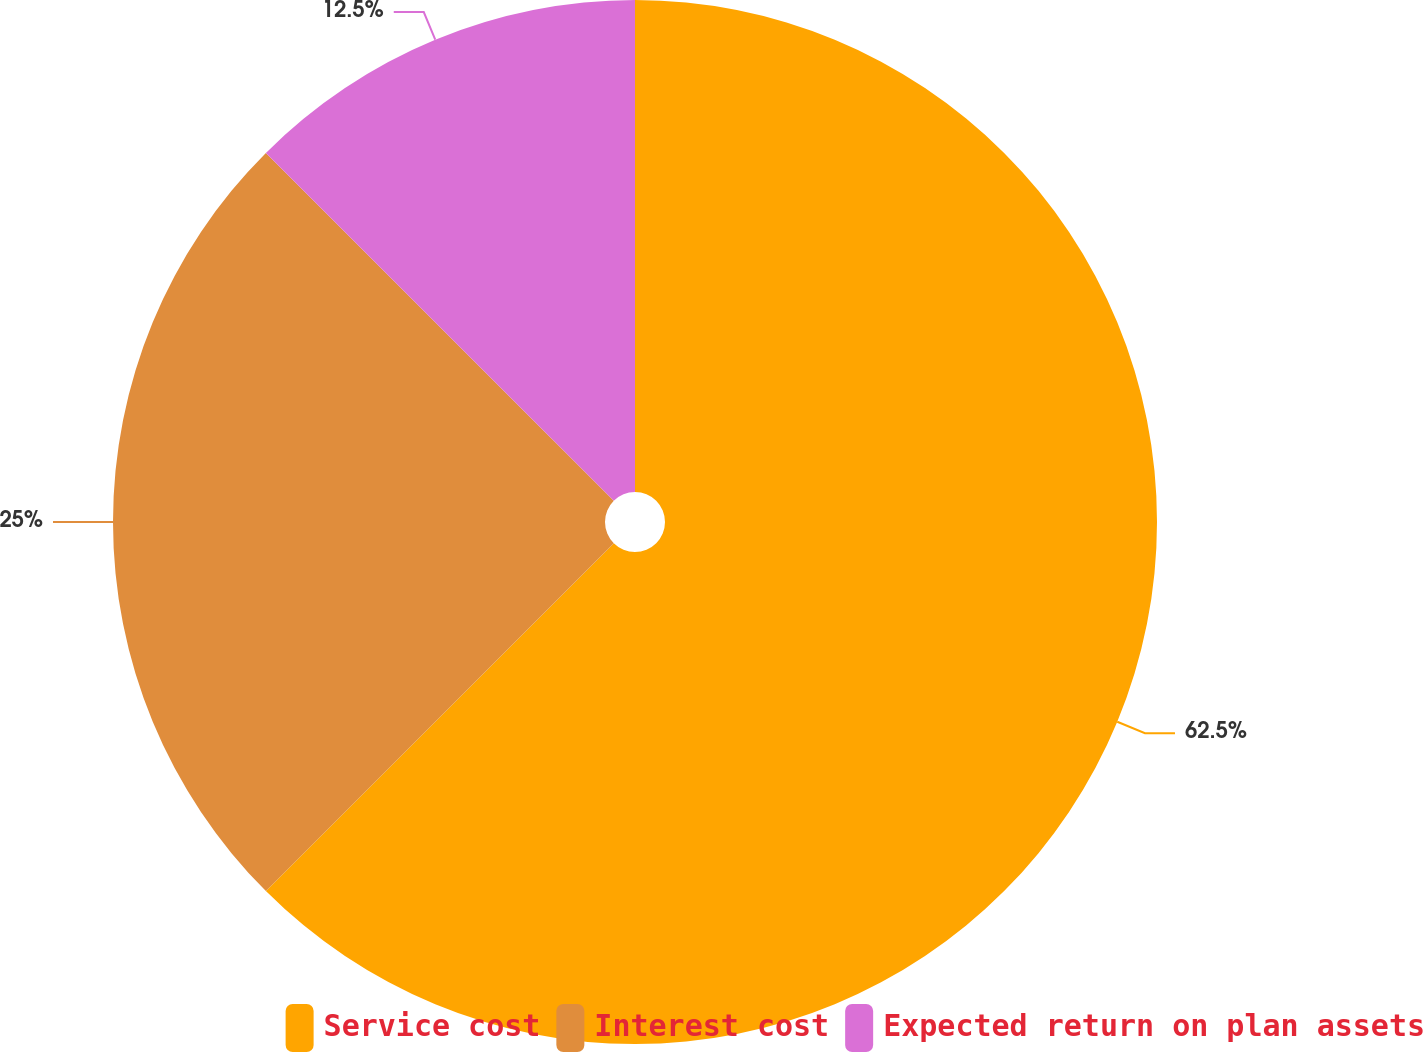Convert chart to OTSL. <chart><loc_0><loc_0><loc_500><loc_500><pie_chart><fcel>Service cost<fcel>Interest cost<fcel>Expected return on plan assets<nl><fcel>62.5%<fcel>25.0%<fcel>12.5%<nl></chart> 